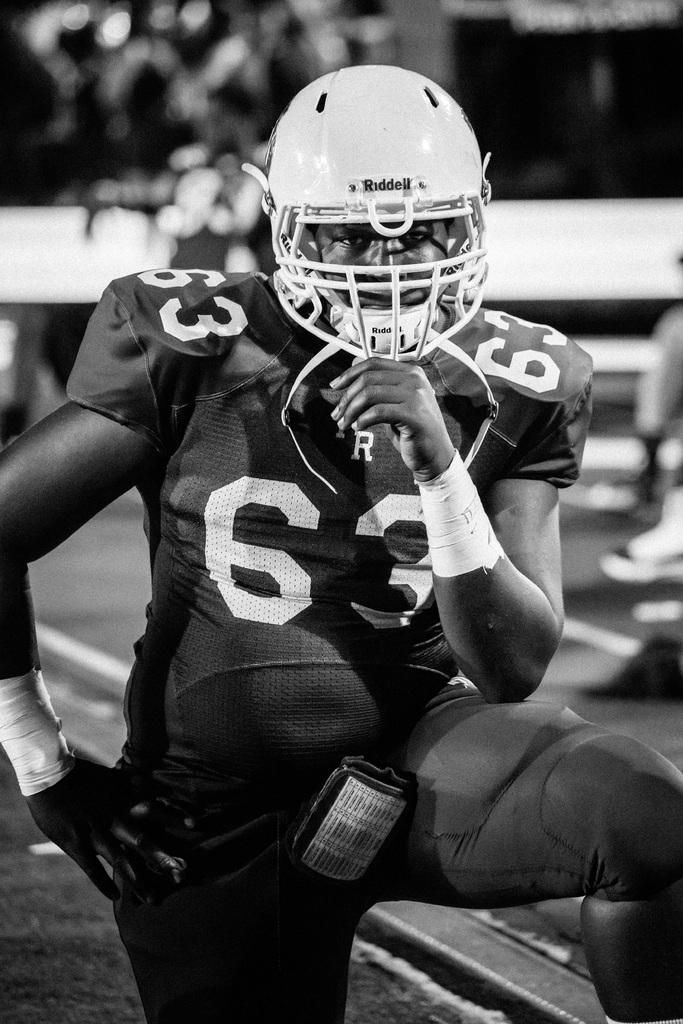What is the color scheme of the image? The image is black and white. Can you describe the main subject of the image? There is a person standing in the image. How many mice are running around the person's feet in the image? There are no mice present in the image; it only features a person standing. What type of natural disaster is happening in the background of the image? There is no natural disaster, such as an earthquake, depicted in the image. 